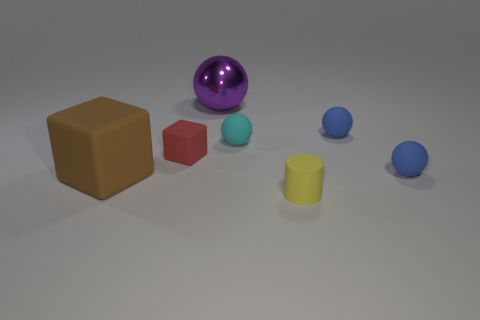What number of things are either small objects in front of the cyan rubber sphere or large yellow rubber objects?
Ensure brevity in your answer.  3. How many objects are blue objects or small things behind the small yellow matte cylinder?
Your response must be concise. 4. What number of yellow objects have the same size as the purple sphere?
Offer a very short reply. 0. Is the number of large cubes that are behind the cylinder less than the number of objects that are in front of the purple shiny thing?
Keep it short and to the point. Yes. What number of rubber objects are either large blue balls or yellow cylinders?
Keep it short and to the point. 1. What shape is the big brown matte thing?
Offer a very short reply. Cube. What material is the thing that is the same size as the brown matte cube?
Keep it short and to the point. Metal. What number of big things are either red objects or purple metal balls?
Provide a succinct answer. 1. Is there a brown rubber cylinder?
Your answer should be very brief. No. There is a yellow object that is the same material as the brown block; what size is it?
Keep it short and to the point. Small. 